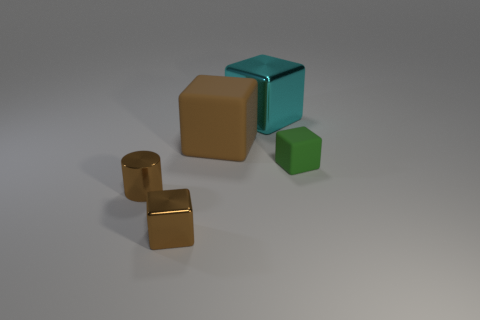Subtract all green blocks. Subtract all cyan spheres. How many blocks are left? 3 Add 2 brown metal cubes. How many objects exist? 7 Subtract all blocks. How many objects are left? 1 Add 5 green rubber blocks. How many green rubber blocks are left? 6 Add 3 small yellow metallic blocks. How many small yellow metallic blocks exist? 3 Subtract 0 gray balls. How many objects are left? 5 Subtract all large cyan metallic blocks. Subtract all big cubes. How many objects are left? 2 